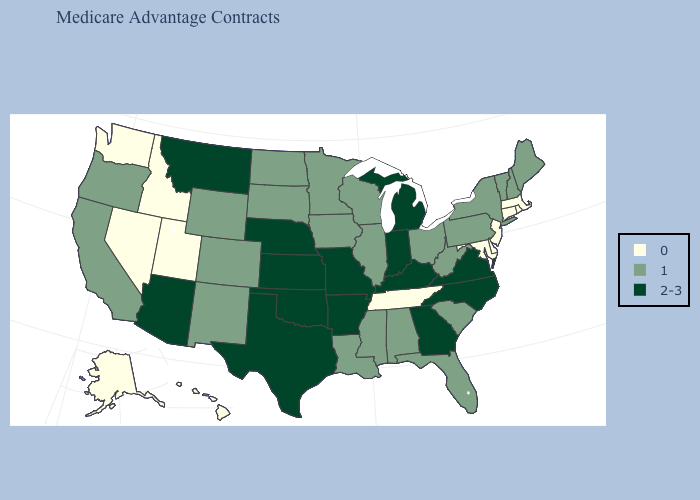What is the lowest value in the USA?
Write a very short answer. 0. How many symbols are there in the legend?
Give a very brief answer. 3. What is the lowest value in the USA?
Quick response, please. 0. What is the value of Louisiana?
Keep it brief. 1. Does Florida have the lowest value in the USA?
Keep it brief. No. How many symbols are there in the legend?
Quick response, please. 3. What is the lowest value in the South?
Be succinct. 0. Name the states that have a value in the range 1?
Concise answer only. Alabama, California, Colorado, Florida, Iowa, Illinois, Louisiana, Maine, Minnesota, Mississippi, North Dakota, New Hampshire, New Mexico, New York, Ohio, Oregon, Pennsylvania, South Carolina, South Dakota, Vermont, Wisconsin, West Virginia, Wyoming. Name the states that have a value in the range 2-3?
Be succinct. Arkansas, Arizona, Georgia, Indiana, Kansas, Kentucky, Michigan, Missouri, Montana, North Carolina, Nebraska, Oklahoma, Texas, Virginia. What is the lowest value in states that border Tennessee?
Be succinct. 1. What is the value of Hawaii?
Write a very short answer. 0. Name the states that have a value in the range 2-3?
Quick response, please. Arkansas, Arizona, Georgia, Indiana, Kansas, Kentucky, Michigan, Missouri, Montana, North Carolina, Nebraska, Oklahoma, Texas, Virginia. What is the value of New Mexico?
Answer briefly. 1. 